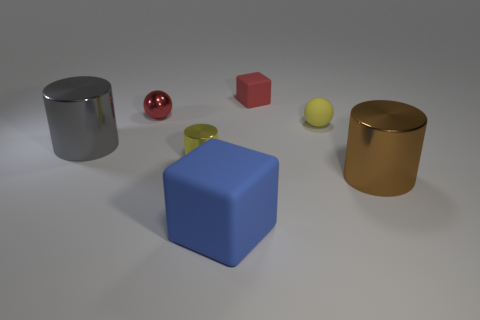What color is the other large rubber thing that is the same shape as the red rubber object?
Offer a very short reply. Blue. There is a object that is both on the right side of the small red block and behind the tiny yellow shiny object; what material is it?
Ensure brevity in your answer.  Rubber. Is the block behind the large blue rubber object made of the same material as the cube in front of the tiny yellow ball?
Give a very brief answer. Yes. How big is the blue thing?
Your answer should be compact. Large. There is a brown thing that is the same shape as the big gray thing; what size is it?
Your answer should be very brief. Large. There is a large brown metallic cylinder; how many small red things are to the left of it?
Keep it short and to the point. 2. What is the color of the tiny thing in front of the tiny ball that is to the right of the big rubber object?
Make the answer very short. Yellow. Is the number of gray metal objects left of the brown metal thing the same as the number of gray things on the left side of the large gray cylinder?
Your answer should be compact. No. How many balls are yellow objects or big metallic objects?
Provide a short and direct response. 1. How many other objects are the same material as the gray cylinder?
Your answer should be very brief. 3. 